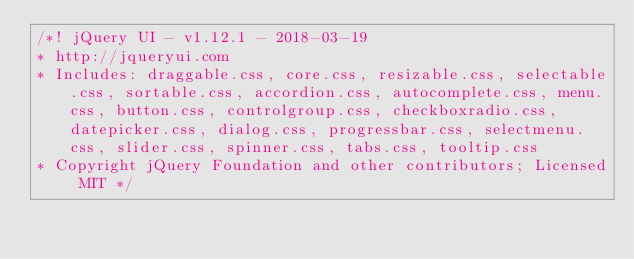Convert code to text. <code><loc_0><loc_0><loc_500><loc_500><_CSS_>/*! jQuery UI - v1.12.1 - 2018-03-19
* http://jqueryui.com
* Includes: draggable.css, core.css, resizable.css, selectable.css, sortable.css, accordion.css, autocomplete.css, menu.css, button.css, controlgroup.css, checkboxradio.css, datepicker.css, dialog.css, progressbar.css, selectmenu.css, slider.css, spinner.css, tabs.css, tooltip.css
* Copyright jQuery Foundation and other contributors; Licensed MIT */
</code> 